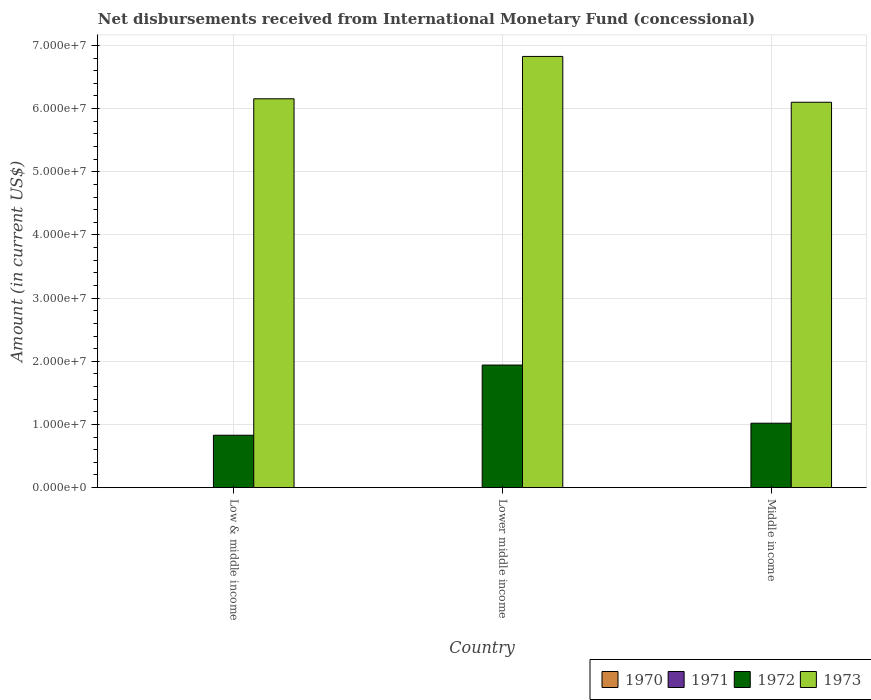How many different coloured bars are there?
Give a very brief answer. 2. How many groups of bars are there?
Offer a very short reply. 3. Are the number of bars on each tick of the X-axis equal?
Keep it short and to the point. Yes. How many bars are there on the 2nd tick from the left?
Your answer should be very brief. 2. How many bars are there on the 2nd tick from the right?
Keep it short and to the point. 2. What is the label of the 2nd group of bars from the left?
Your answer should be very brief. Lower middle income. In how many cases, is the number of bars for a given country not equal to the number of legend labels?
Your response must be concise. 3. Across all countries, what is the maximum amount of disbursements received from International Monetary Fund in 1972?
Ensure brevity in your answer.  1.94e+07. Across all countries, what is the minimum amount of disbursements received from International Monetary Fund in 1972?
Make the answer very short. 8.30e+06. In which country was the amount of disbursements received from International Monetary Fund in 1973 maximum?
Give a very brief answer. Lower middle income. What is the total amount of disbursements received from International Monetary Fund in 1973 in the graph?
Offer a terse response. 1.91e+08. What is the difference between the amount of disbursements received from International Monetary Fund in 1973 in Lower middle income and that in Middle income?
Offer a terse response. 7.25e+06. What is the difference between the amount of disbursements received from International Monetary Fund in 1971 in Lower middle income and the amount of disbursements received from International Monetary Fund in 1973 in Middle income?
Give a very brief answer. -6.10e+07. What is the average amount of disbursements received from International Monetary Fund in 1973 per country?
Offer a very short reply. 6.36e+07. What is the ratio of the amount of disbursements received from International Monetary Fund in 1973 in Low & middle income to that in Lower middle income?
Your response must be concise. 0.9. Is the amount of disbursements received from International Monetary Fund in 1973 in Lower middle income less than that in Middle income?
Provide a succinct answer. No. What is the difference between the highest and the second highest amount of disbursements received from International Monetary Fund in 1973?
Your answer should be very brief. -7.25e+06. What is the difference between the highest and the lowest amount of disbursements received from International Monetary Fund in 1972?
Your answer should be compact. 1.11e+07. In how many countries, is the amount of disbursements received from International Monetary Fund in 1971 greater than the average amount of disbursements received from International Monetary Fund in 1971 taken over all countries?
Your answer should be very brief. 0. How many bars are there?
Ensure brevity in your answer.  6. Are all the bars in the graph horizontal?
Provide a succinct answer. No. Does the graph contain any zero values?
Offer a very short reply. Yes. How many legend labels are there?
Your answer should be compact. 4. How are the legend labels stacked?
Give a very brief answer. Horizontal. What is the title of the graph?
Make the answer very short. Net disbursements received from International Monetary Fund (concessional). Does "1985" appear as one of the legend labels in the graph?
Ensure brevity in your answer.  No. What is the label or title of the X-axis?
Provide a succinct answer. Country. What is the label or title of the Y-axis?
Make the answer very short. Amount (in current US$). What is the Amount (in current US$) in 1971 in Low & middle income?
Offer a very short reply. 0. What is the Amount (in current US$) in 1972 in Low & middle income?
Your answer should be very brief. 8.30e+06. What is the Amount (in current US$) of 1973 in Low & middle income?
Make the answer very short. 6.16e+07. What is the Amount (in current US$) in 1971 in Lower middle income?
Provide a succinct answer. 0. What is the Amount (in current US$) in 1972 in Lower middle income?
Keep it short and to the point. 1.94e+07. What is the Amount (in current US$) of 1973 in Lower middle income?
Offer a terse response. 6.83e+07. What is the Amount (in current US$) of 1970 in Middle income?
Your answer should be very brief. 0. What is the Amount (in current US$) of 1971 in Middle income?
Give a very brief answer. 0. What is the Amount (in current US$) in 1972 in Middle income?
Make the answer very short. 1.02e+07. What is the Amount (in current US$) in 1973 in Middle income?
Make the answer very short. 6.10e+07. Across all countries, what is the maximum Amount (in current US$) of 1972?
Your answer should be compact. 1.94e+07. Across all countries, what is the maximum Amount (in current US$) in 1973?
Your answer should be compact. 6.83e+07. Across all countries, what is the minimum Amount (in current US$) of 1972?
Offer a terse response. 8.30e+06. Across all countries, what is the minimum Amount (in current US$) in 1973?
Provide a short and direct response. 6.10e+07. What is the total Amount (in current US$) in 1971 in the graph?
Provide a succinct answer. 0. What is the total Amount (in current US$) of 1972 in the graph?
Offer a very short reply. 3.79e+07. What is the total Amount (in current US$) in 1973 in the graph?
Keep it short and to the point. 1.91e+08. What is the difference between the Amount (in current US$) in 1972 in Low & middle income and that in Lower middle income?
Give a very brief answer. -1.11e+07. What is the difference between the Amount (in current US$) of 1973 in Low & middle income and that in Lower middle income?
Your response must be concise. -6.70e+06. What is the difference between the Amount (in current US$) in 1972 in Low & middle income and that in Middle income?
Provide a short and direct response. -1.90e+06. What is the difference between the Amount (in current US$) of 1973 in Low & middle income and that in Middle income?
Your response must be concise. 5.46e+05. What is the difference between the Amount (in current US$) of 1972 in Lower middle income and that in Middle income?
Keep it short and to the point. 9.21e+06. What is the difference between the Amount (in current US$) in 1973 in Lower middle income and that in Middle income?
Offer a terse response. 7.25e+06. What is the difference between the Amount (in current US$) of 1972 in Low & middle income and the Amount (in current US$) of 1973 in Lower middle income?
Your answer should be compact. -6.00e+07. What is the difference between the Amount (in current US$) of 1972 in Low & middle income and the Amount (in current US$) of 1973 in Middle income?
Your answer should be very brief. -5.27e+07. What is the difference between the Amount (in current US$) of 1972 in Lower middle income and the Amount (in current US$) of 1973 in Middle income?
Your response must be concise. -4.16e+07. What is the average Amount (in current US$) of 1970 per country?
Keep it short and to the point. 0. What is the average Amount (in current US$) in 1971 per country?
Give a very brief answer. 0. What is the average Amount (in current US$) of 1972 per country?
Your answer should be compact. 1.26e+07. What is the average Amount (in current US$) of 1973 per country?
Offer a very short reply. 6.36e+07. What is the difference between the Amount (in current US$) in 1972 and Amount (in current US$) in 1973 in Low & middle income?
Make the answer very short. -5.33e+07. What is the difference between the Amount (in current US$) in 1972 and Amount (in current US$) in 1973 in Lower middle income?
Your answer should be compact. -4.89e+07. What is the difference between the Amount (in current US$) of 1972 and Amount (in current US$) of 1973 in Middle income?
Your response must be concise. -5.08e+07. What is the ratio of the Amount (in current US$) of 1972 in Low & middle income to that in Lower middle income?
Keep it short and to the point. 0.43. What is the ratio of the Amount (in current US$) in 1973 in Low & middle income to that in Lower middle income?
Provide a short and direct response. 0.9. What is the ratio of the Amount (in current US$) in 1972 in Low & middle income to that in Middle income?
Offer a very short reply. 0.81. What is the ratio of the Amount (in current US$) of 1972 in Lower middle income to that in Middle income?
Make the answer very short. 1.9. What is the ratio of the Amount (in current US$) of 1973 in Lower middle income to that in Middle income?
Keep it short and to the point. 1.12. What is the difference between the highest and the second highest Amount (in current US$) of 1972?
Offer a very short reply. 9.21e+06. What is the difference between the highest and the second highest Amount (in current US$) in 1973?
Ensure brevity in your answer.  6.70e+06. What is the difference between the highest and the lowest Amount (in current US$) of 1972?
Ensure brevity in your answer.  1.11e+07. What is the difference between the highest and the lowest Amount (in current US$) of 1973?
Make the answer very short. 7.25e+06. 